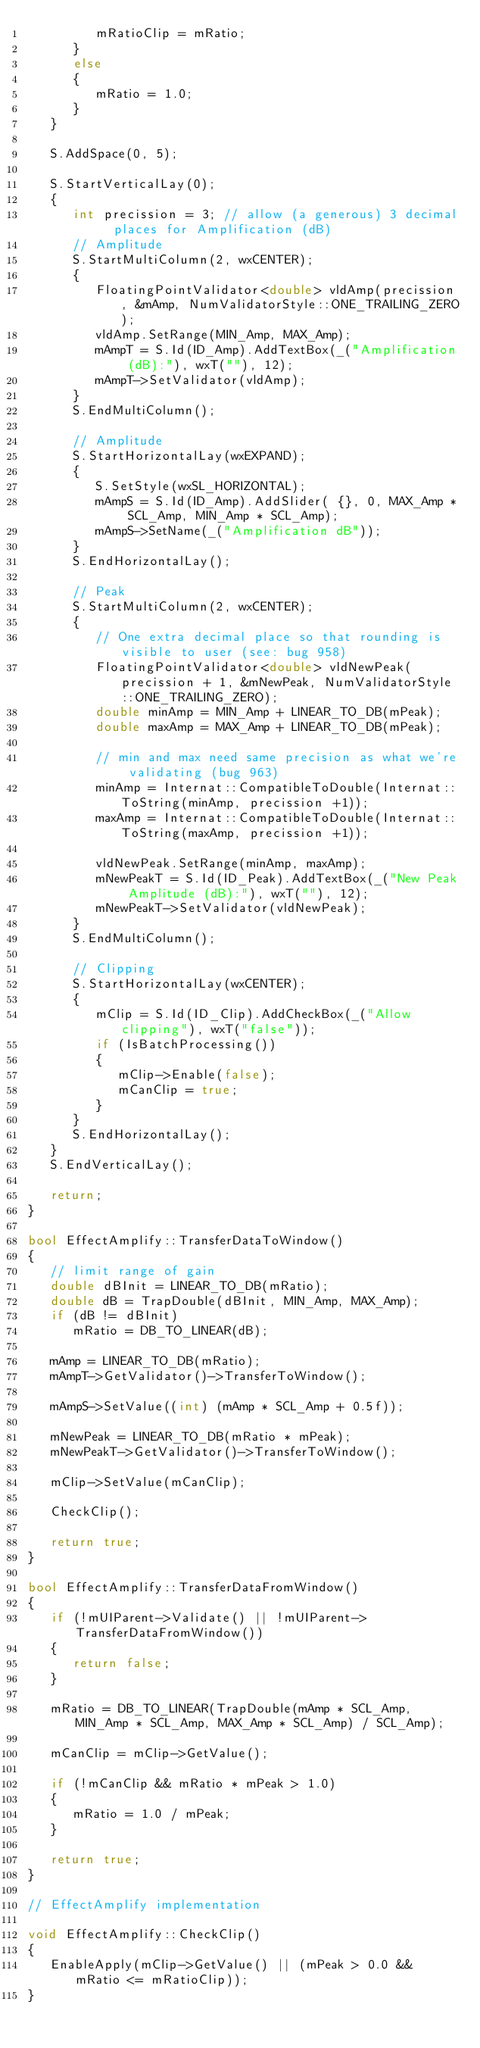<code> <loc_0><loc_0><loc_500><loc_500><_C++_>         mRatioClip = mRatio;
      }
      else
      {
         mRatio = 1.0;
      }
   }

   S.AddSpace(0, 5);

   S.StartVerticalLay(0);
   {
      int precission = 3; // allow (a generous) 3 decimal  places for Amplification (dB)
      // Amplitude
      S.StartMultiColumn(2, wxCENTER);
      {
         FloatingPointValidator<double> vldAmp(precission, &mAmp, NumValidatorStyle::ONE_TRAILING_ZERO);
         vldAmp.SetRange(MIN_Amp, MAX_Amp);
         mAmpT = S.Id(ID_Amp).AddTextBox(_("Amplification (dB):"), wxT(""), 12);
         mAmpT->SetValidator(vldAmp);
      }
      S.EndMultiColumn();

      // Amplitude
      S.StartHorizontalLay(wxEXPAND);
      {
         S.SetStyle(wxSL_HORIZONTAL);
         mAmpS = S.Id(ID_Amp).AddSlider( {}, 0, MAX_Amp * SCL_Amp, MIN_Amp * SCL_Amp);
         mAmpS->SetName(_("Amplification dB"));
      }
      S.EndHorizontalLay();

      // Peak
      S.StartMultiColumn(2, wxCENTER);
      {
         // One extra decimal place so that rounding is visible to user (see: bug 958)
         FloatingPointValidator<double> vldNewPeak(precission + 1, &mNewPeak, NumValidatorStyle::ONE_TRAILING_ZERO);
         double minAmp = MIN_Amp + LINEAR_TO_DB(mPeak);
         double maxAmp = MAX_Amp + LINEAR_TO_DB(mPeak);

         // min and max need same precision as what we're validating (bug 963)
         minAmp = Internat::CompatibleToDouble(Internat::ToString(minAmp, precission +1));
         maxAmp = Internat::CompatibleToDouble(Internat::ToString(maxAmp, precission +1));

         vldNewPeak.SetRange(minAmp, maxAmp);
         mNewPeakT = S.Id(ID_Peak).AddTextBox(_("New Peak Amplitude (dB):"), wxT(""), 12);
         mNewPeakT->SetValidator(vldNewPeak);
      }
      S.EndMultiColumn();

      // Clipping
      S.StartHorizontalLay(wxCENTER);
      {
         mClip = S.Id(ID_Clip).AddCheckBox(_("Allow clipping"), wxT("false"));
         if (IsBatchProcessing())
         {
            mClip->Enable(false);
            mCanClip = true;
         }
      }
      S.EndHorizontalLay();
   }
   S.EndVerticalLay();

   return;
}

bool EffectAmplify::TransferDataToWindow()
{
   // limit range of gain
   double dBInit = LINEAR_TO_DB(mRatio);
   double dB = TrapDouble(dBInit, MIN_Amp, MAX_Amp);
   if (dB != dBInit)
      mRatio = DB_TO_LINEAR(dB);

   mAmp = LINEAR_TO_DB(mRatio);
   mAmpT->GetValidator()->TransferToWindow();

   mAmpS->SetValue((int) (mAmp * SCL_Amp + 0.5f));

   mNewPeak = LINEAR_TO_DB(mRatio * mPeak);
   mNewPeakT->GetValidator()->TransferToWindow();

   mClip->SetValue(mCanClip);

   CheckClip();

   return true;
}

bool EffectAmplify::TransferDataFromWindow()
{
   if (!mUIParent->Validate() || !mUIParent->TransferDataFromWindow())
   {
      return false;
   }

   mRatio = DB_TO_LINEAR(TrapDouble(mAmp * SCL_Amp, MIN_Amp * SCL_Amp, MAX_Amp * SCL_Amp) / SCL_Amp);

   mCanClip = mClip->GetValue();

   if (!mCanClip && mRatio * mPeak > 1.0)
   {
      mRatio = 1.0 / mPeak;
   }

   return true;
}

// EffectAmplify implementation

void EffectAmplify::CheckClip()
{
   EnableApply(mClip->GetValue() || (mPeak > 0.0 && mRatio <= mRatioClip));
}
</code> 